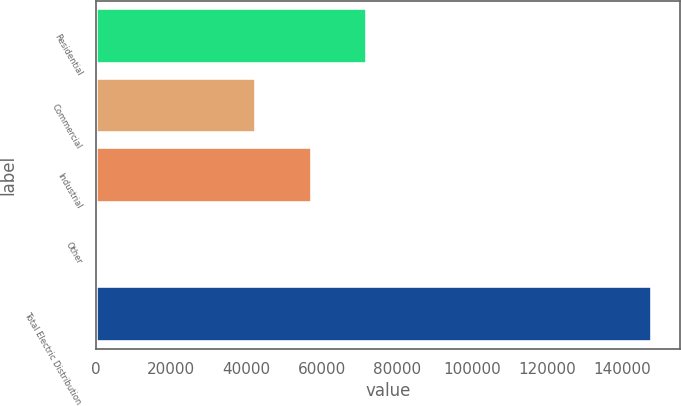Convert chart to OTSL. <chart><loc_0><loc_0><loc_500><loc_500><bar_chart><fcel>Residential<fcel>Commercial<fcel>Industrial<fcel>Other<fcel>Total Electric Distribution<nl><fcel>72042.8<fcel>42582<fcel>57312.4<fcel>584<fcel>147888<nl></chart> 